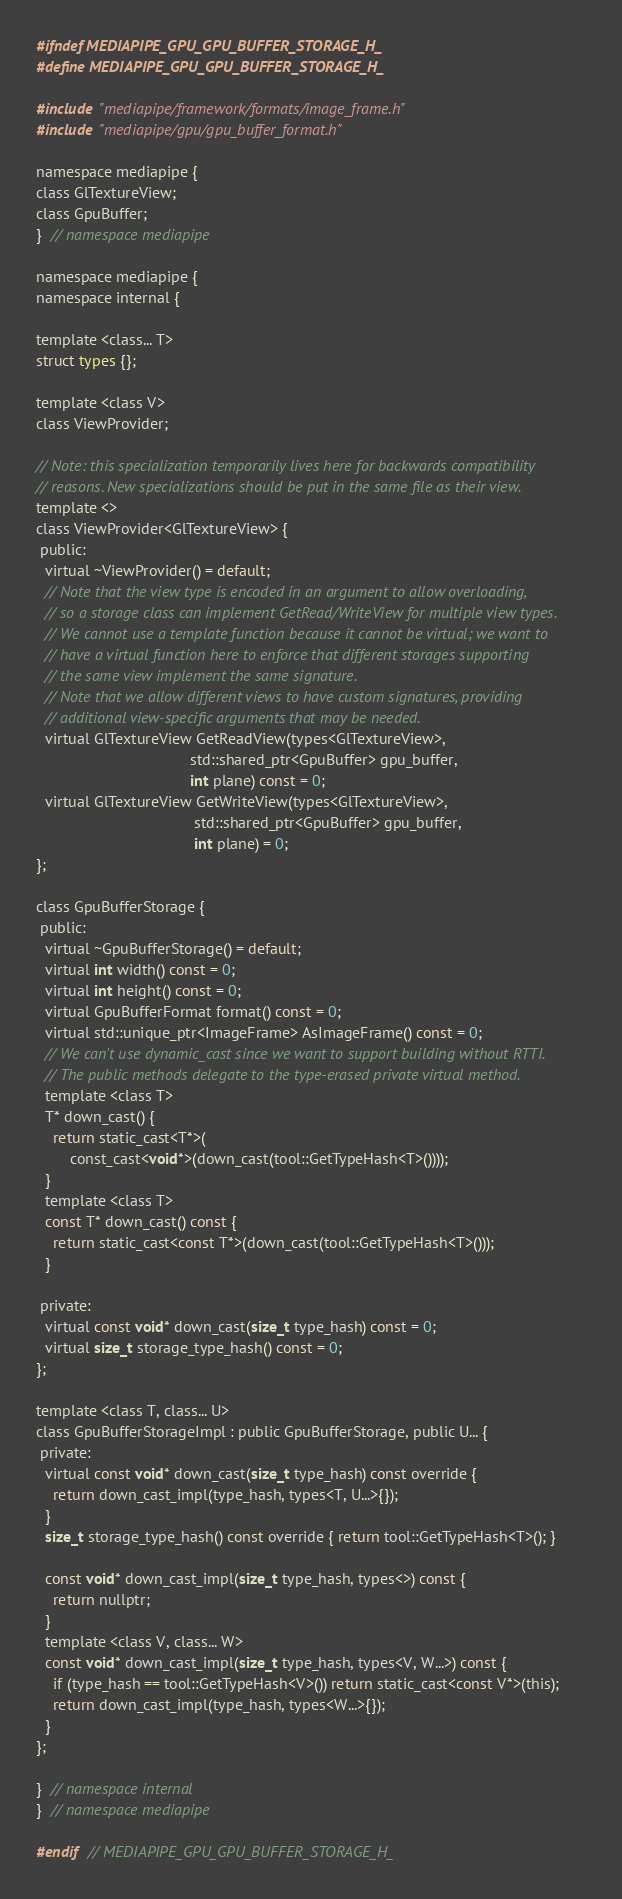<code> <loc_0><loc_0><loc_500><loc_500><_C_>#ifndef MEDIAPIPE_GPU_GPU_BUFFER_STORAGE_H_
#define MEDIAPIPE_GPU_GPU_BUFFER_STORAGE_H_

#include "mediapipe/framework/formats/image_frame.h"
#include "mediapipe/gpu/gpu_buffer_format.h"

namespace mediapipe {
class GlTextureView;
class GpuBuffer;
}  // namespace mediapipe

namespace mediapipe {
namespace internal {

template <class... T>
struct types {};

template <class V>
class ViewProvider;

// Note: this specialization temporarily lives here for backwards compatibility
// reasons. New specializations should be put in the same file as their view.
template <>
class ViewProvider<GlTextureView> {
 public:
  virtual ~ViewProvider() = default;
  // Note that the view type is encoded in an argument to allow overloading,
  // so a storage class can implement GetRead/WriteView for multiple view types.
  // We cannot use a template function because it cannot be virtual; we want to
  // have a virtual function here to enforce that different storages supporting
  // the same view implement the same signature.
  // Note that we allow different views to have custom signatures, providing
  // additional view-specific arguments that may be needed.
  virtual GlTextureView GetReadView(types<GlTextureView>,
                                    std::shared_ptr<GpuBuffer> gpu_buffer,
                                    int plane) const = 0;
  virtual GlTextureView GetWriteView(types<GlTextureView>,
                                     std::shared_ptr<GpuBuffer> gpu_buffer,
                                     int plane) = 0;
};

class GpuBufferStorage {
 public:
  virtual ~GpuBufferStorage() = default;
  virtual int width() const = 0;
  virtual int height() const = 0;
  virtual GpuBufferFormat format() const = 0;
  virtual std::unique_ptr<ImageFrame> AsImageFrame() const = 0;
  // We can't use dynamic_cast since we want to support building without RTTI.
  // The public methods delegate to the type-erased private virtual method.
  template <class T>
  T* down_cast() {
    return static_cast<T*>(
        const_cast<void*>(down_cast(tool::GetTypeHash<T>())));
  }
  template <class T>
  const T* down_cast() const {
    return static_cast<const T*>(down_cast(tool::GetTypeHash<T>()));
  }

 private:
  virtual const void* down_cast(size_t type_hash) const = 0;
  virtual size_t storage_type_hash() const = 0;
};

template <class T, class... U>
class GpuBufferStorageImpl : public GpuBufferStorage, public U... {
 private:
  virtual const void* down_cast(size_t type_hash) const override {
    return down_cast_impl(type_hash, types<T, U...>{});
  }
  size_t storage_type_hash() const override { return tool::GetTypeHash<T>(); }

  const void* down_cast_impl(size_t type_hash, types<>) const {
    return nullptr;
  }
  template <class V, class... W>
  const void* down_cast_impl(size_t type_hash, types<V, W...>) const {
    if (type_hash == tool::GetTypeHash<V>()) return static_cast<const V*>(this);
    return down_cast_impl(type_hash, types<W...>{});
  }
};

}  // namespace internal
}  // namespace mediapipe

#endif  // MEDIAPIPE_GPU_GPU_BUFFER_STORAGE_H_
</code> 